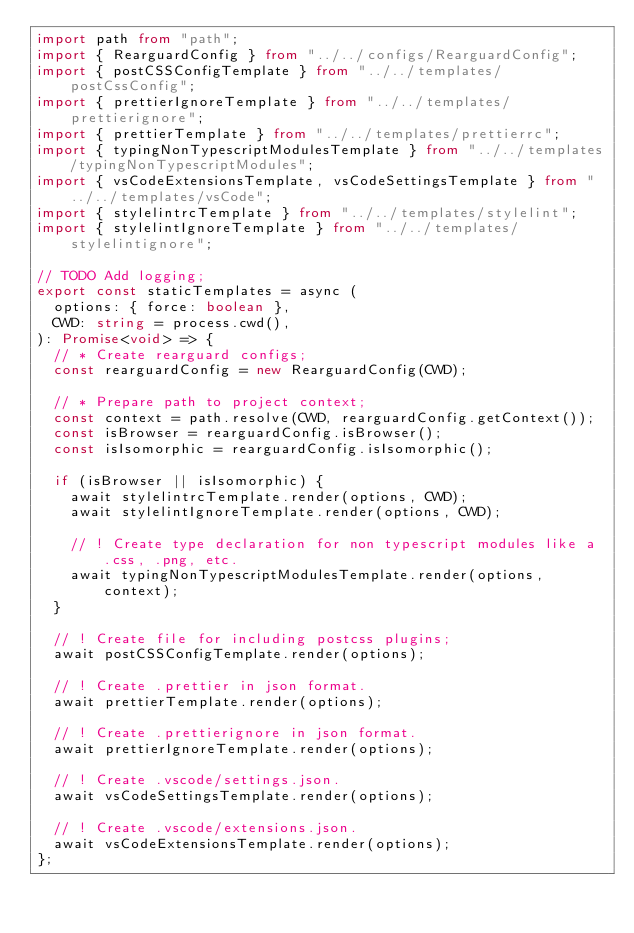<code> <loc_0><loc_0><loc_500><loc_500><_TypeScript_>import path from "path";
import { RearguardConfig } from "../../configs/RearguardConfig";
import { postCSSConfigTemplate } from "../../templates/postCssConfig";
import { prettierIgnoreTemplate } from "../../templates/prettierignore";
import { prettierTemplate } from "../../templates/prettierrc";
import { typingNonTypescriptModulesTemplate } from "../../templates/typingNonTypescriptModules";
import { vsCodeExtensionsTemplate, vsCodeSettingsTemplate } from "../../templates/vsCode";
import { stylelintrcTemplate } from "../../templates/stylelint";
import { stylelintIgnoreTemplate } from "../../templates/stylelintignore";

// TODO Add logging;
export const staticTemplates = async (
  options: { force: boolean },
  CWD: string = process.cwd(),
): Promise<void> => {
  // * Create rearguard configs;
  const rearguardConfig = new RearguardConfig(CWD);

  // * Prepare path to project context;
  const context = path.resolve(CWD, rearguardConfig.getContext());
  const isBrowser = rearguardConfig.isBrowser();
  const isIsomorphic = rearguardConfig.isIsomorphic();

  if (isBrowser || isIsomorphic) {
    await stylelintrcTemplate.render(options, CWD);
    await stylelintIgnoreTemplate.render(options, CWD);

    // ! Create type declaration for non typescript modules like a .css, .png, etc.
    await typingNonTypescriptModulesTemplate.render(options, context);
  }

  // ! Create file for including postcss plugins;
  await postCSSConfigTemplate.render(options);

  // ! Create .prettier in json format.
  await prettierTemplate.render(options);

  // ! Create .prettierignore in json format.
  await prettierIgnoreTemplate.render(options);

  // ! Create .vscode/settings.json.
  await vsCodeSettingsTemplate.render(options);

  // ! Create .vscode/extensions.json.
  await vsCodeExtensionsTemplate.render(options);
};
</code> 